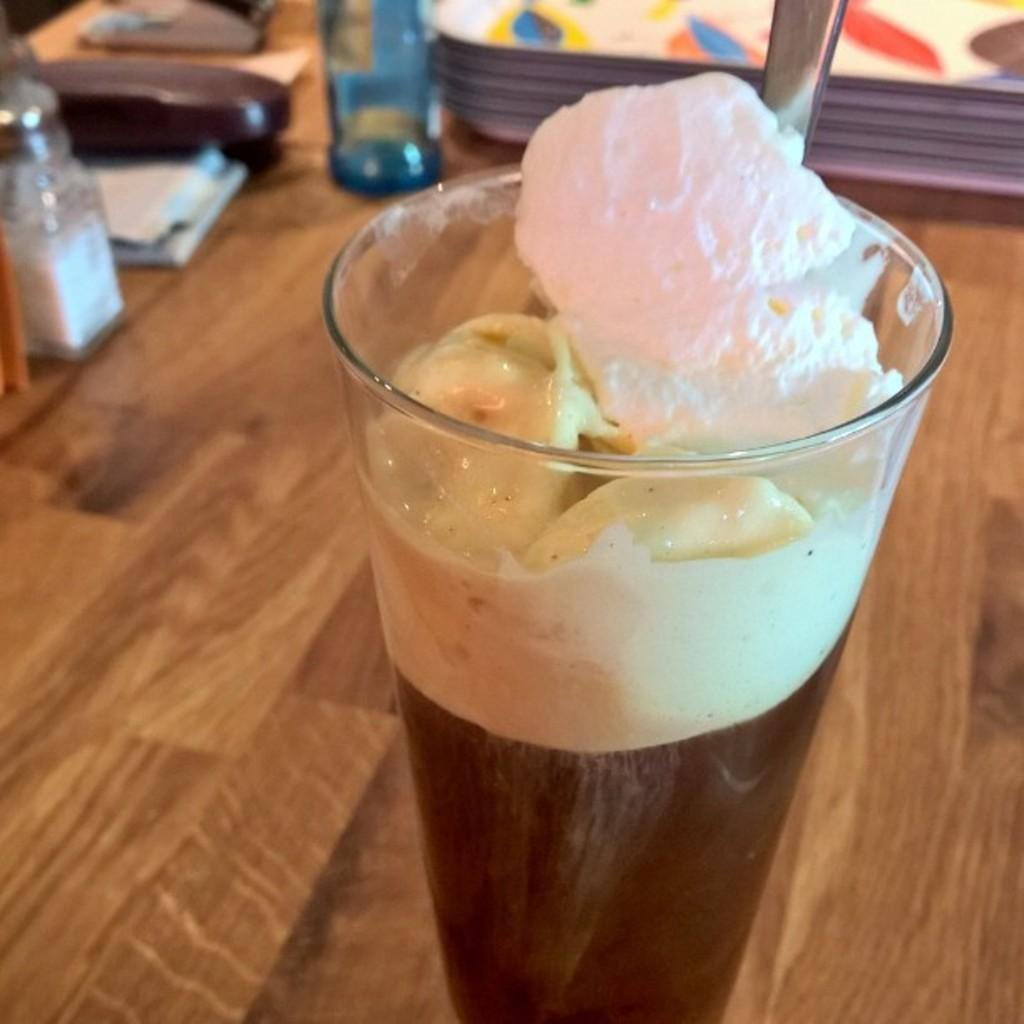What is in the glass that is visible in the image? The glass contains ice cream and liquid. What object is used for stirring or scooping in the image? There is a spoon in the image, and it is on the table. What type of bone can be seen in the image? There is no bone present in the image. What tools might a carpenter use in the image? There is no carpenter or carpentry tools present in the image. 